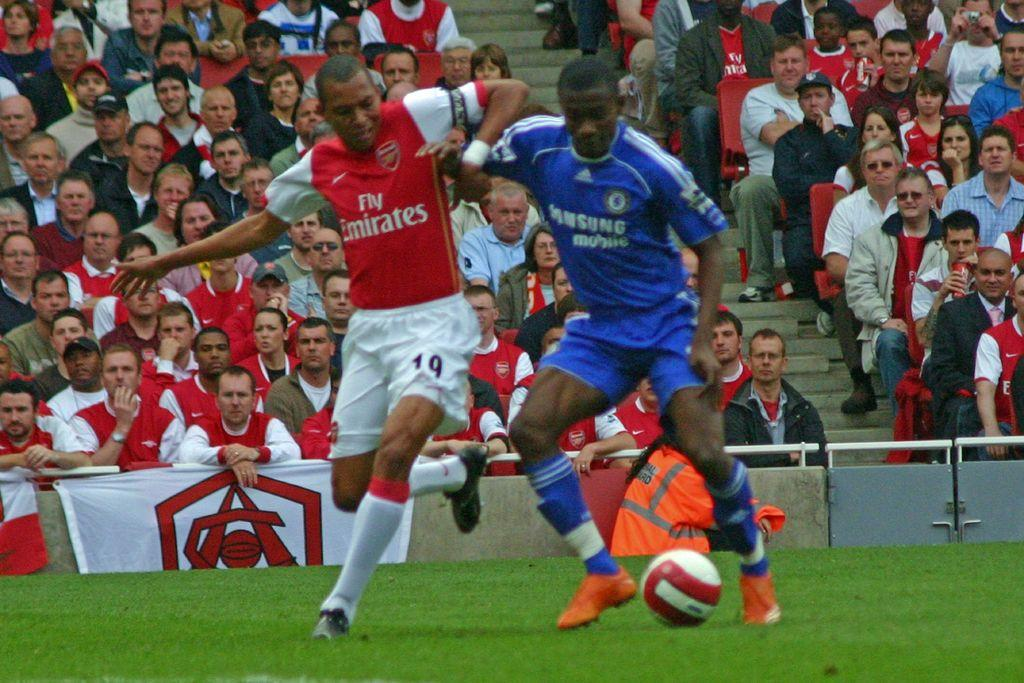<image>
Present a compact description of the photo's key features. Two soccer players go toe to toe, one in an Emirates uniform and the other wearing a Samsung outfit. 